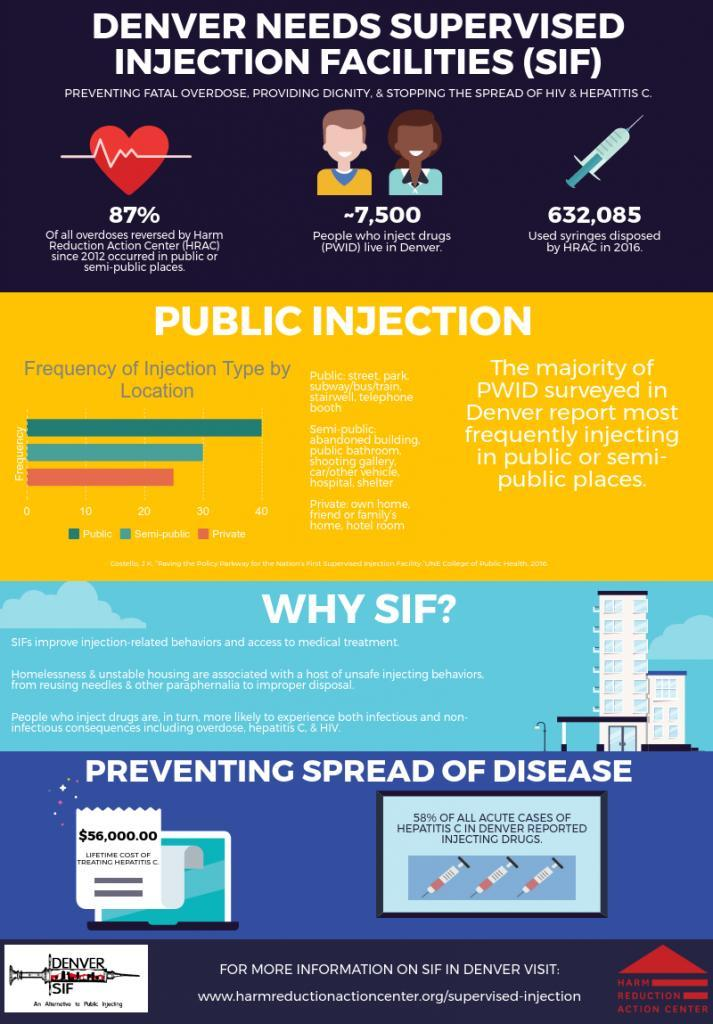what location is a shooting gallery
Answer the question with a short phrase. semi-public what is the colour of hear, white or red red what is the lifetime cost of treatment of Hepatatis C $56,000.00 what location is a hotel room private what location is a telephone booth public in which location is the frequency the second highest semi-public 